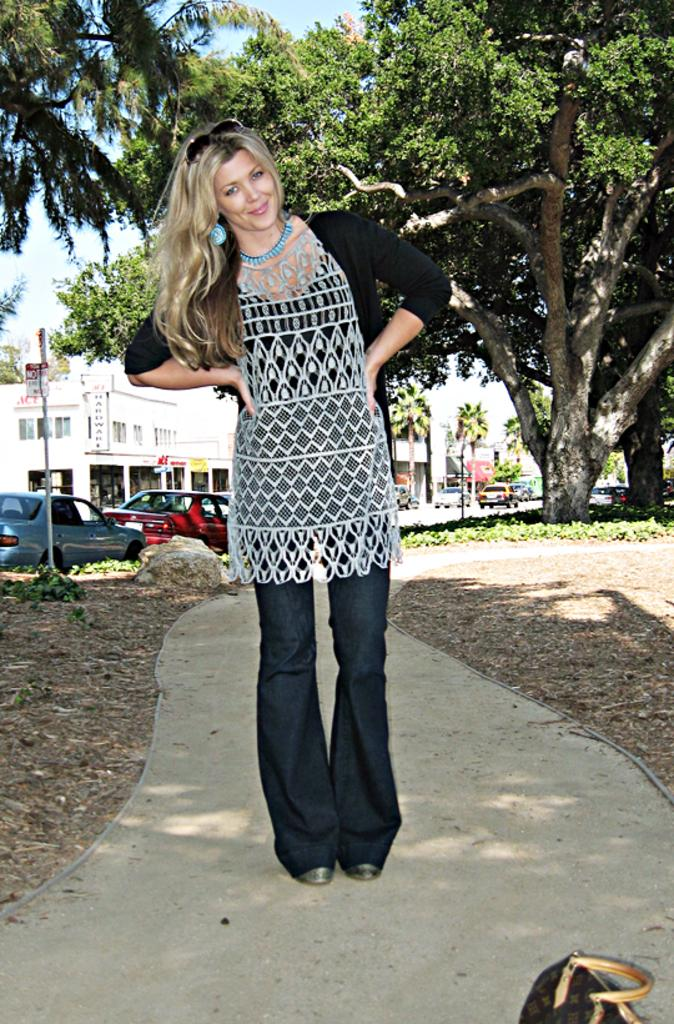Who are the main subjects in the image? There are women in the center of the image. What can be seen in the background of the image? There are cars, buildings, trees, and the sky visible in the background of the image. What type of plastic material is being used by the band in the image? There is no band present in the image, and therefore no plastic material being used by them. 